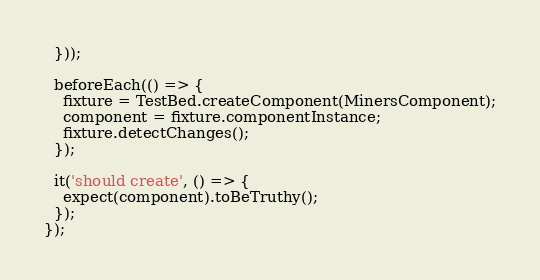Convert code to text. <code><loc_0><loc_0><loc_500><loc_500><_TypeScript_>  }));

  beforeEach(() => {
    fixture = TestBed.createComponent(MinersComponent);
    component = fixture.componentInstance;
    fixture.detectChanges();
  });

  it('should create', () => {
    expect(component).toBeTruthy();
  });
});
</code> 